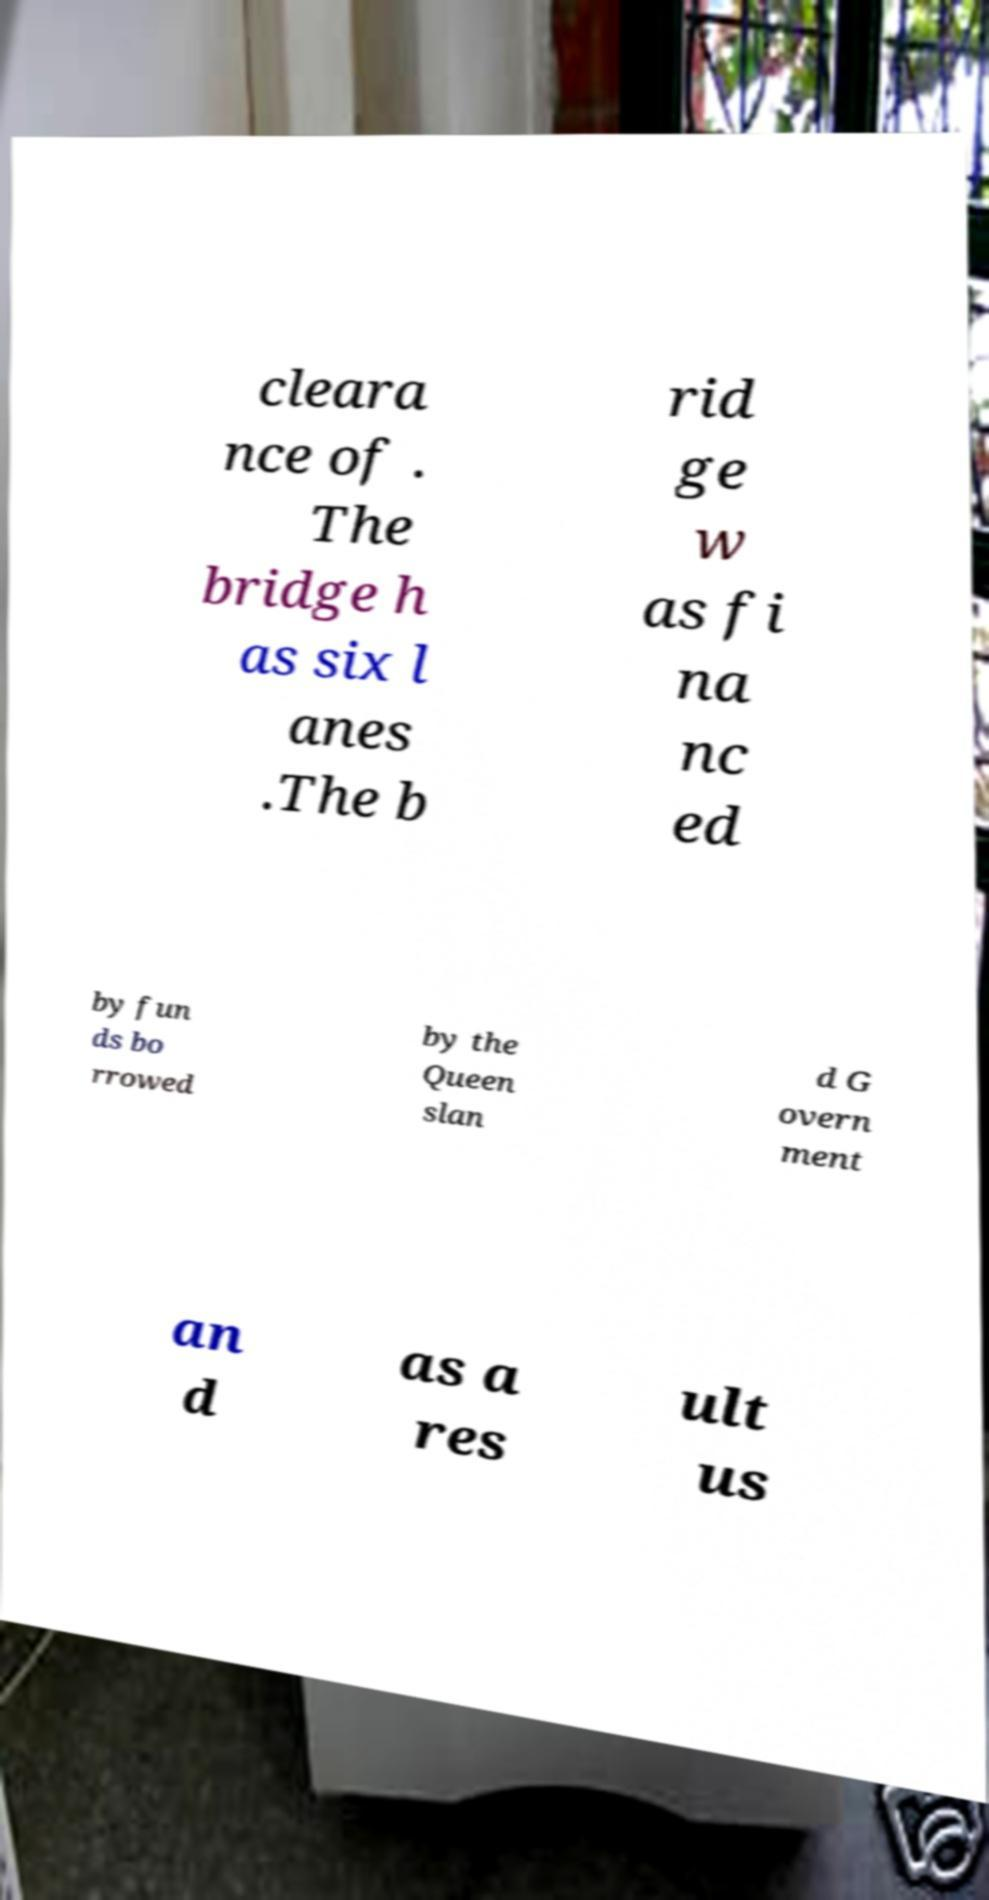Could you extract and type out the text from this image? cleara nce of . The bridge h as six l anes .The b rid ge w as fi na nc ed by fun ds bo rrowed by the Queen slan d G overn ment an d as a res ult us 